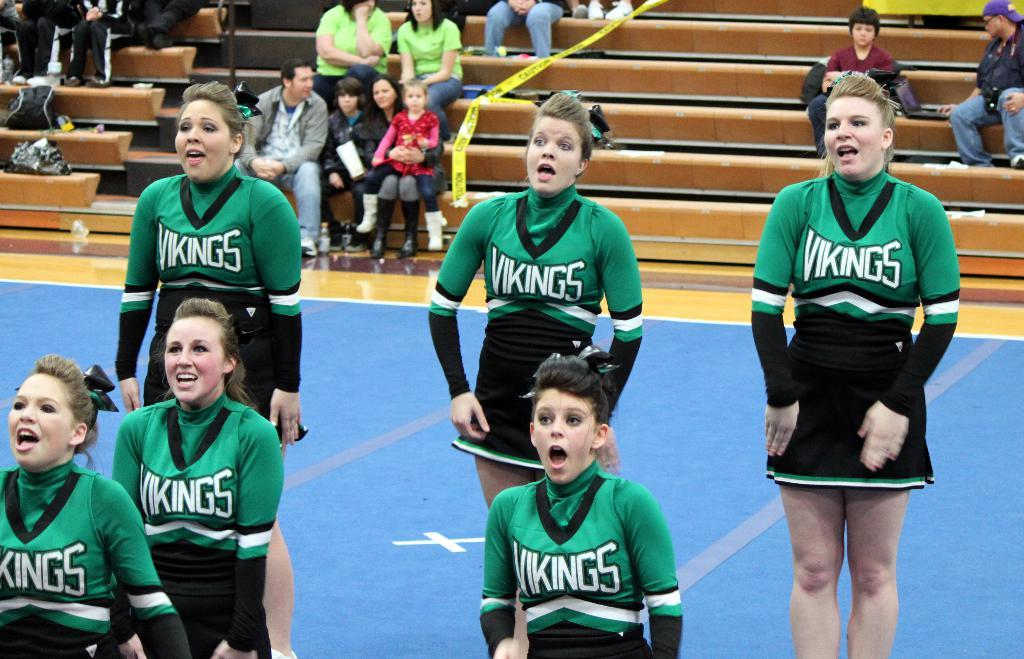<image>
Write a terse but informative summary of the picture. Vikings reads the team name on these cheerleader's uniforms. 